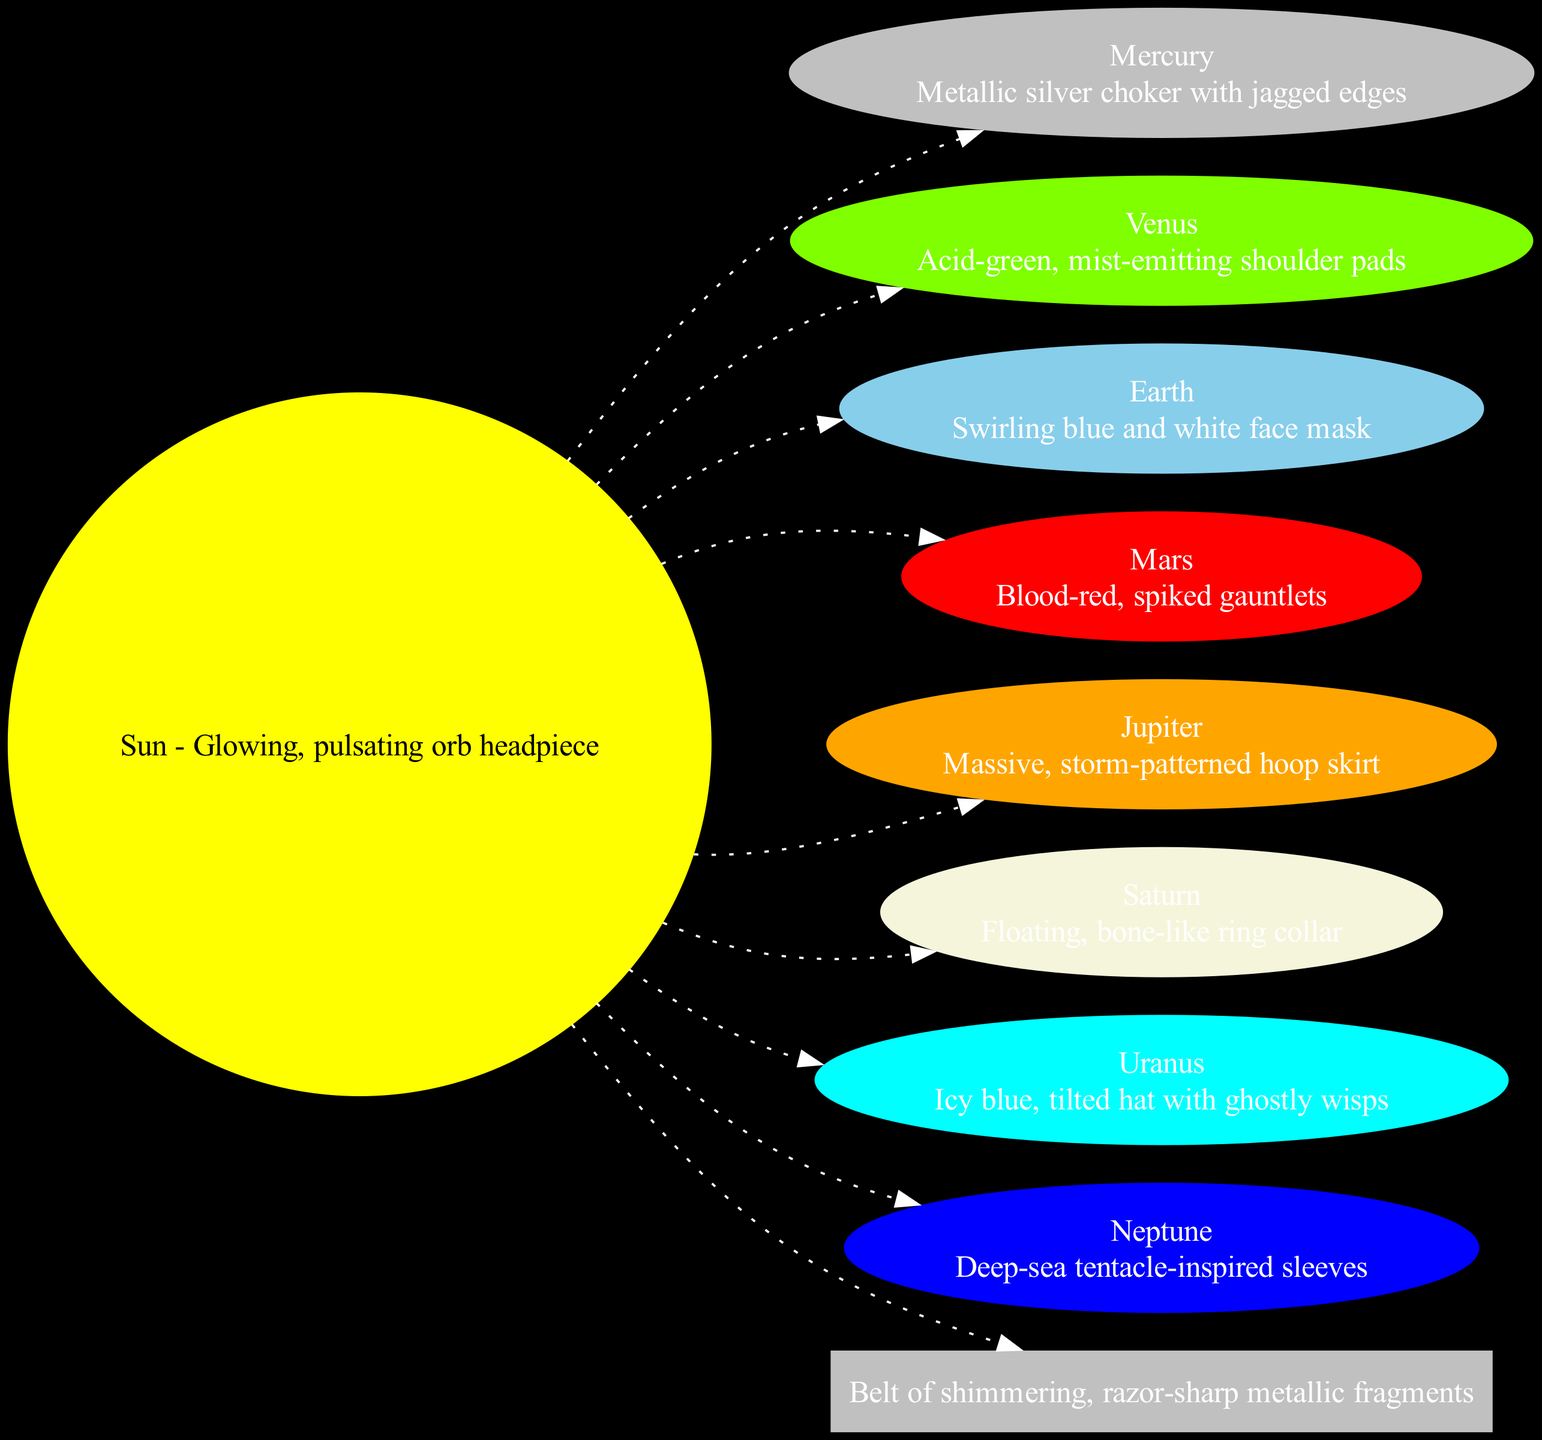What does Mercury represent in this diagram? In the diagram, Mercury is visually represented as a "Metallic silver choker with jagged edges". The label for Mercury indicates this specific description.
Answer: Metallic silver choker with jagged edges How many planets are depicted in the diagram? The diagram includes eight planets as nodes, which can be counted from the list provided in the data. They are: Mercury, Venus, Earth, Mars, Jupiter, Saturn, Uranus, and Neptune.
Answer: 8 What accessory corresponds to Saturn? In the diagram, Saturn is represented as a "Floating, bone-like ring collar". This is found in the description for the Saturn node.
Answer: Floating, bone-like ring collar Which planet is represented by blood-red, spiked gauntlets? The description directly states that Mars is represented by "Blood-red, spiked gauntlets" in the planet nodes section of the diagram.
Answer: Mars What connects the Sun to the asteroid belt? The edge connecting the Sun to the asteroid belt is labeled with a dotted line indicating a relationship, specifically showing that the asteroid belt is part of the solar system and is connected to the Sun.
Answer: Asteroid Belt What color is the floating ring collar associated with Saturn? There is no explicit color mentioned for Saturn's accessory in the node; however, the diagram uses the term "bone-like," which suggests a neutral or off-white color concept. The color used in the node for Saturn is beige.
Answer: Beige Which planet accessory is associated with acid-green? Venus is described as having "Acid-green, mist-emitting shoulder pads", making it clear that it represents this specific color and design in the diagram.
Answer: Venus Which accessory in the diagram is inspired by the sea? Neptune's description mentions "Deep-sea tentacle-inspired sleeves", indicating a direct relationship to oceanic themes in its accessory representation.
Answer: Deep-sea tentacle-inspired sleeves 